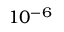Convert formula to latex. <formula><loc_0><loc_0><loc_500><loc_500>1 0 ^ { - 6 }</formula> 